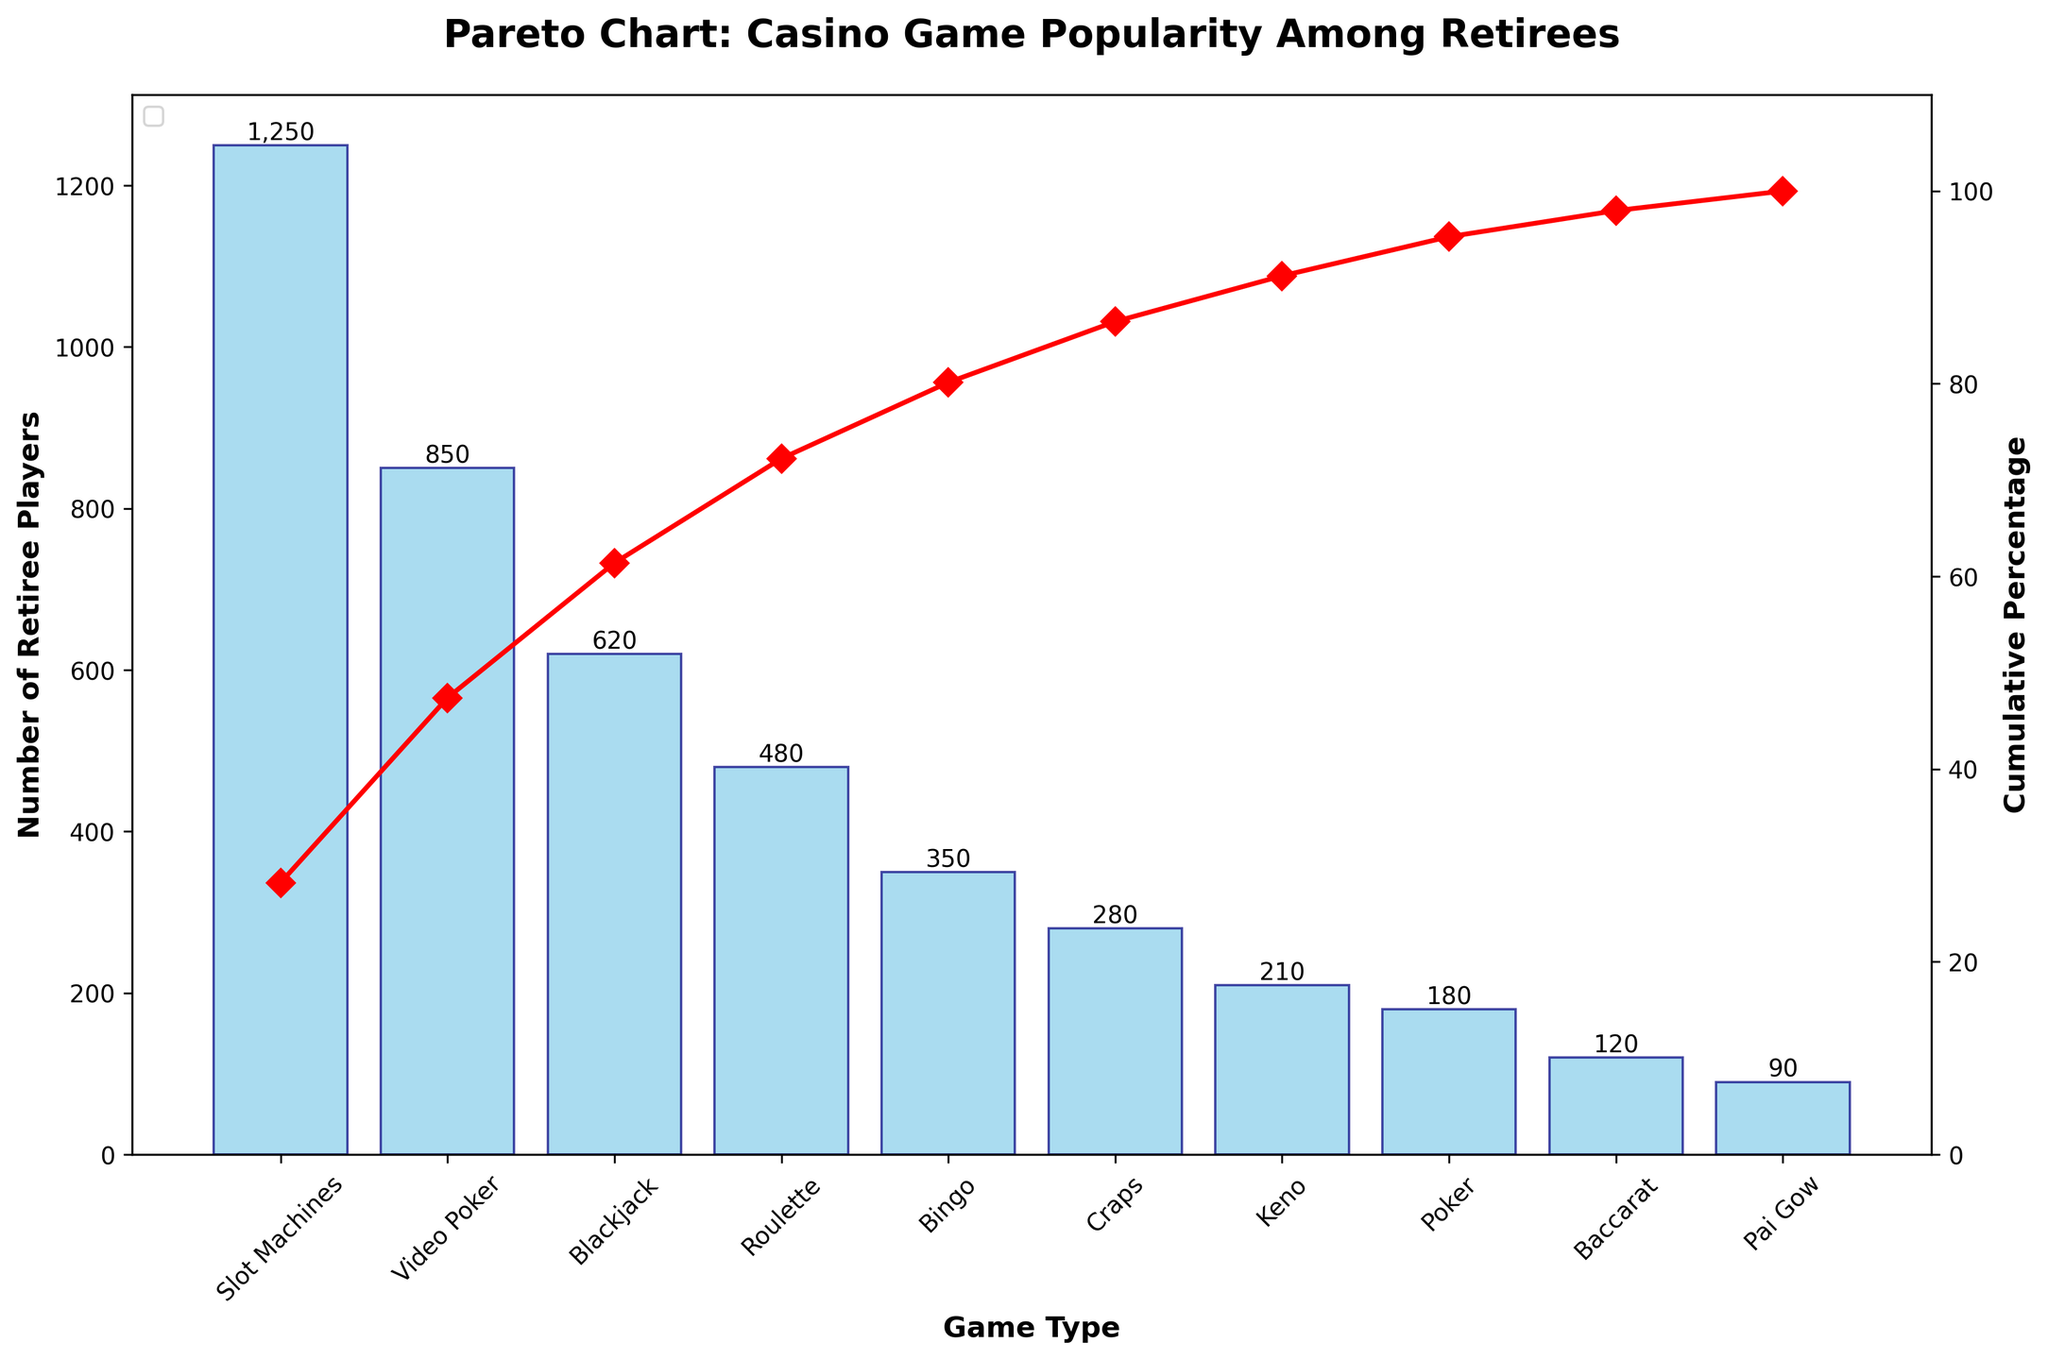What's the title of the chart? The title is at the top of the figure, clearly stating the purpose of the chart.
Answer: Pareto Chart: Casino Game Popularity Among Retirees How many game types are shown in the chart? The x-axis lists the game types, and each bar represents a different game. Counting the bars gives the total number of game types.
Answer: 10 Which game type has the highest number of retiree players? The tallest bar represents the game type with the highest number of players.
Answer: Slot Machines What is the cumulative percentage after adding Blackjack players? Locate Blackjack on the x-axis, follow the cumulative percentage line to where it meets the secondary y-axis.
Answer: 63.6% How does the number of Video Poker players compare to Baccarat players? Locate both game types on the x-axis; compare the heights of their bars.
Answer: Video Poker has more players What's the total number of retiree players for Slot Machines and Bingo combined? Sum the heights of the bars for Slot Machines (1250) and Bingo (350).
Answer: 1600 What's the cumulative percentage just after Roulette? Locate Roulette on the x-axis, follow the cumulative percentage line to where it meets the secondary y-axis.
Answer: 85.6% What is the difference in the number of players between Poker and Pai Gow? Locate both game types on the x-axis and subtract the height of Pai Gow's bar (90) from Poker's bar (180).
Answer: 90 How many players are needed to reach the 80% cumulative percentage mark? Identify the game types and their bars that cumulatively fulfill or exceed 80% when combined.
Answer: 3200 (after Blackjack) Among Keno, Baccarat, and Pai Gow, which game has the lowest number of retiree players? Compare the heights of the bars for Keno (210), Baccarat (120), and Pai Gow (90).
Answer: Pai Gow 